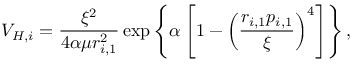<formula> <loc_0><loc_0><loc_500><loc_500>V _ { H , i } = \frac { \xi ^ { 2 } } { 4 \alpha \mu r _ { i , 1 } ^ { 2 } } \exp \left \{ \alpha \left [ 1 - \left ( \frac { r _ { i , 1 } p _ { i , 1 } } { \xi } \right ) ^ { 4 } \right ] \right \} ,</formula> 